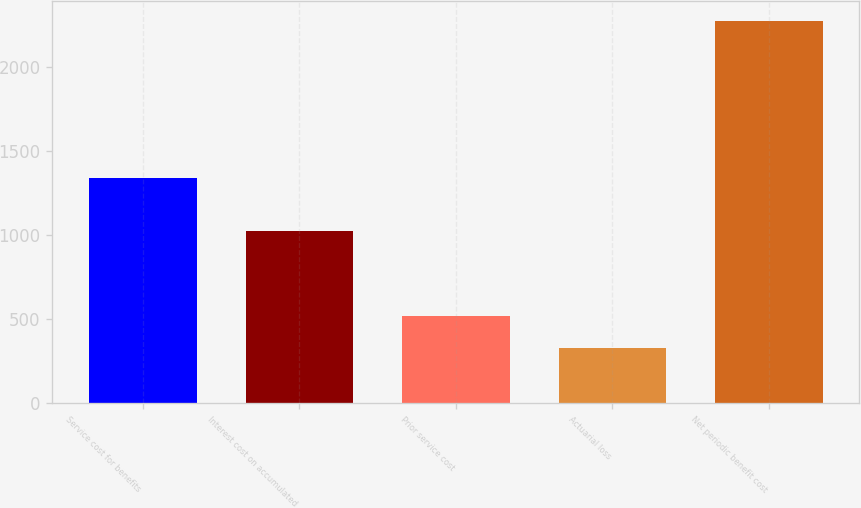Convert chart to OTSL. <chart><loc_0><loc_0><loc_500><loc_500><bar_chart><fcel>Service cost for benefits<fcel>Interest cost on accumulated<fcel>Prior service cost<fcel>Actuarial loss<fcel>Net periodic benefit cost<nl><fcel>1341<fcel>1022<fcel>522.7<fcel>328<fcel>2275<nl></chart> 